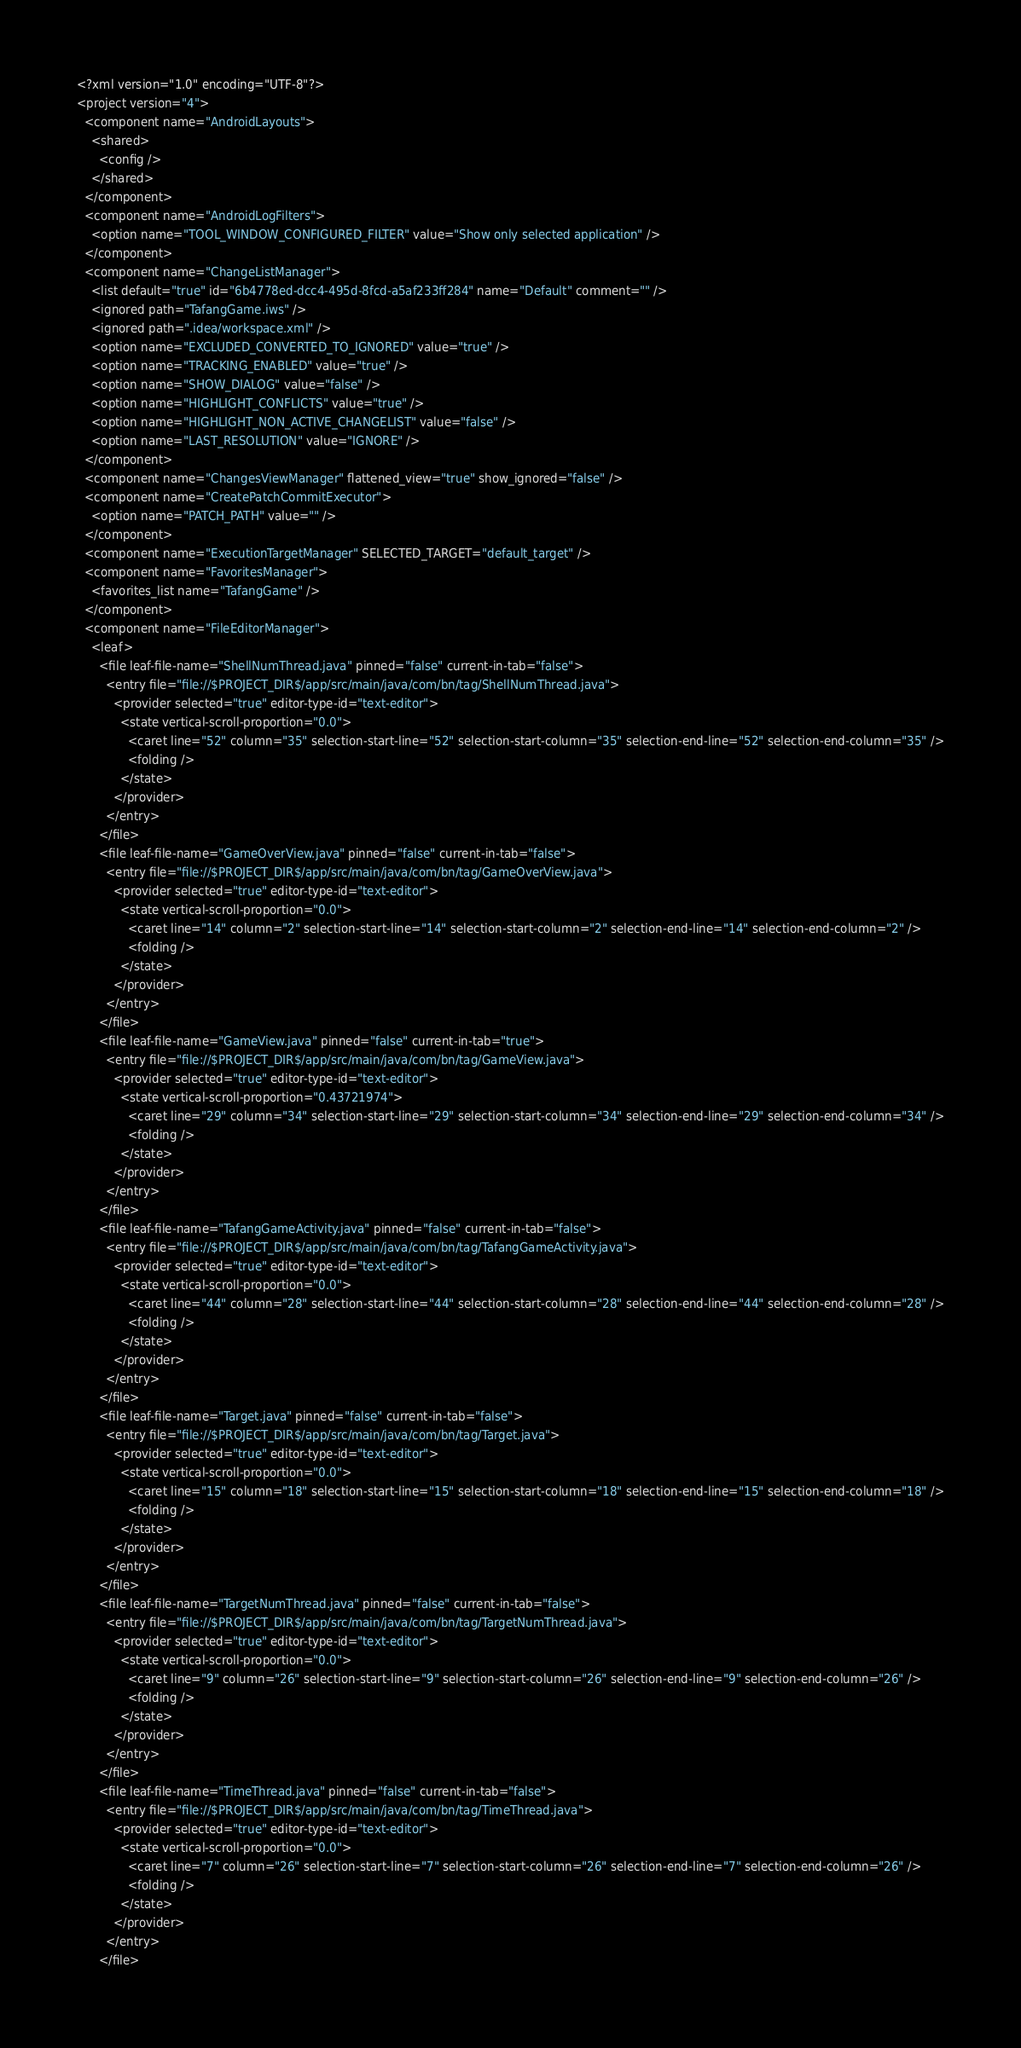Convert code to text. <code><loc_0><loc_0><loc_500><loc_500><_XML_><?xml version="1.0" encoding="UTF-8"?>
<project version="4">
  <component name="AndroidLayouts">
    <shared>
      <config />
    </shared>
  </component>
  <component name="AndroidLogFilters">
    <option name="TOOL_WINDOW_CONFIGURED_FILTER" value="Show only selected application" />
  </component>
  <component name="ChangeListManager">
    <list default="true" id="6b4778ed-dcc4-495d-8fcd-a5af233ff284" name="Default" comment="" />
    <ignored path="TafangGame.iws" />
    <ignored path=".idea/workspace.xml" />
    <option name="EXCLUDED_CONVERTED_TO_IGNORED" value="true" />
    <option name="TRACKING_ENABLED" value="true" />
    <option name="SHOW_DIALOG" value="false" />
    <option name="HIGHLIGHT_CONFLICTS" value="true" />
    <option name="HIGHLIGHT_NON_ACTIVE_CHANGELIST" value="false" />
    <option name="LAST_RESOLUTION" value="IGNORE" />
  </component>
  <component name="ChangesViewManager" flattened_view="true" show_ignored="false" />
  <component name="CreatePatchCommitExecutor">
    <option name="PATCH_PATH" value="" />
  </component>
  <component name="ExecutionTargetManager" SELECTED_TARGET="default_target" />
  <component name="FavoritesManager">
    <favorites_list name="TafangGame" />
  </component>
  <component name="FileEditorManager">
    <leaf>
      <file leaf-file-name="ShellNumThread.java" pinned="false" current-in-tab="false">
        <entry file="file://$PROJECT_DIR$/app/src/main/java/com/bn/tag/ShellNumThread.java">
          <provider selected="true" editor-type-id="text-editor">
            <state vertical-scroll-proportion="0.0">
              <caret line="52" column="35" selection-start-line="52" selection-start-column="35" selection-end-line="52" selection-end-column="35" />
              <folding />
            </state>
          </provider>
        </entry>
      </file>
      <file leaf-file-name="GameOverView.java" pinned="false" current-in-tab="false">
        <entry file="file://$PROJECT_DIR$/app/src/main/java/com/bn/tag/GameOverView.java">
          <provider selected="true" editor-type-id="text-editor">
            <state vertical-scroll-proportion="0.0">
              <caret line="14" column="2" selection-start-line="14" selection-start-column="2" selection-end-line="14" selection-end-column="2" />
              <folding />
            </state>
          </provider>
        </entry>
      </file>
      <file leaf-file-name="GameView.java" pinned="false" current-in-tab="true">
        <entry file="file://$PROJECT_DIR$/app/src/main/java/com/bn/tag/GameView.java">
          <provider selected="true" editor-type-id="text-editor">
            <state vertical-scroll-proportion="0.43721974">
              <caret line="29" column="34" selection-start-line="29" selection-start-column="34" selection-end-line="29" selection-end-column="34" />
              <folding />
            </state>
          </provider>
        </entry>
      </file>
      <file leaf-file-name="TafangGameActivity.java" pinned="false" current-in-tab="false">
        <entry file="file://$PROJECT_DIR$/app/src/main/java/com/bn/tag/TafangGameActivity.java">
          <provider selected="true" editor-type-id="text-editor">
            <state vertical-scroll-proportion="0.0">
              <caret line="44" column="28" selection-start-line="44" selection-start-column="28" selection-end-line="44" selection-end-column="28" />
              <folding />
            </state>
          </provider>
        </entry>
      </file>
      <file leaf-file-name="Target.java" pinned="false" current-in-tab="false">
        <entry file="file://$PROJECT_DIR$/app/src/main/java/com/bn/tag/Target.java">
          <provider selected="true" editor-type-id="text-editor">
            <state vertical-scroll-proportion="0.0">
              <caret line="15" column="18" selection-start-line="15" selection-start-column="18" selection-end-line="15" selection-end-column="18" />
              <folding />
            </state>
          </provider>
        </entry>
      </file>
      <file leaf-file-name="TargetNumThread.java" pinned="false" current-in-tab="false">
        <entry file="file://$PROJECT_DIR$/app/src/main/java/com/bn/tag/TargetNumThread.java">
          <provider selected="true" editor-type-id="text-editor">
            <state vertical-scroll-proportion="0.0">
              <caret line="9" column="26" selection-start-line="9" selection-start-column="26" selection-end-line="9" selection-end-column="26" />
              <folding />
            </state>
          </provider>
        </entry>
      </file>
      <file leaf-file-name="TimeThread.java" pinned="false" current-in-tab="false">
        <entry file="file://$PROJECT_DIR$/app/src/main/java/com/bn/tag/TimeThread.java">
          <provider selected="true" editor-type-id="text-editor">
            <state vertical-scroll-proportion="0.0">
              <caret line="7" column="26" selection-start-line="7" selection-start-column="26" selection-end-line="7" selection-end-column="26" />
              <folding />
            </state>
          </provider>
        </entry>
      </file></code> 